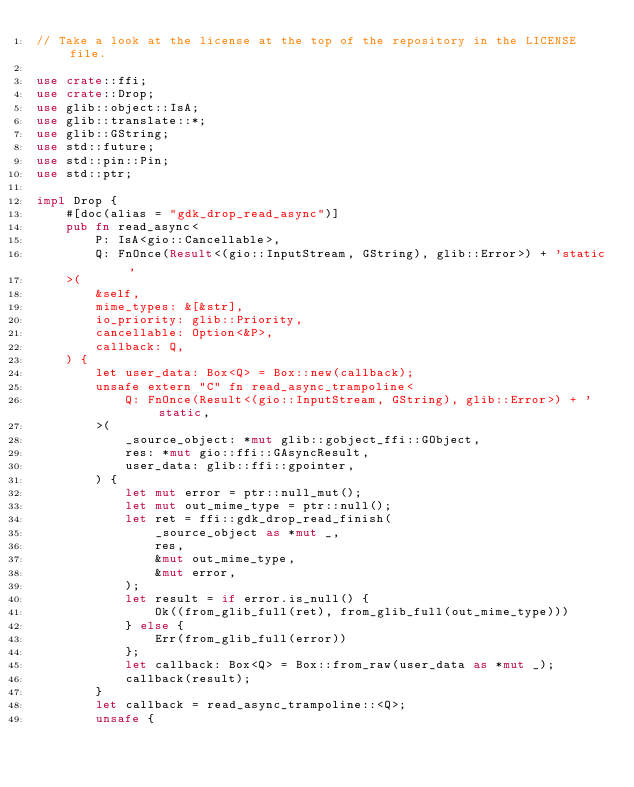<code> <loc_0><loc_0><loc_500><loc_500><_Rust_>// Take a look at the license at the top of the repository in the LICENSE file.

use crate::ffi;
use crate::Drop;
use glib::object::IsA;
use glib::translate::*;
use glib::GString;
use std::future;
use std::pin::Pin;
use std::ptr;

impl Drop {
    #[doc(alias = "gdk_drop_read_async")]
    pub fn read_async<
        P: IsA<gio::Cancellable>,
        Q: FnOnce(Result<(gio::InputStream, GString), glib::Error>) + 'static,
    >(
        &self,
        mime_types: &[&str],
        io_priority: glib::Priority,
        cancellable: Option<&P>,
        callback: Q,
    ) {
        let user_data: Box<Q> = Box::new(callback);
        unsafe extern "C" fn read_async_trampoline<
            Q: FnOnce(Result<(gio::InputStream, GString), glib::Error>) + 'static,
        >(
            _source_object: *mut glib::gobject_ffi::GObject,
            res: *mut gio::ffi::GAsyncResult,
            user_data: glib::ffi::gpointer,
        ) {
            let mut error = ptr::null_mut();
            let mut out_mime_type = ptr::null();
            let ret = ffi::gdk_drop_read_finish(
                _source_object as *mut _,
                res,
                &mut out_mime_type,
                &mut error,
            );
            let result = if error.is_null() {
                Ok((from_glib_full(ret), from_glib_full(out_mime_type)))
            } else {
                Err(from_glib_full(error))
            };
            let callback: Box<Q> = Box::from_raw(user_data as *mut _);
            callback(result);
        }
        let callback = read_async_trampoline::<Q>;
        unsafe {</code> 